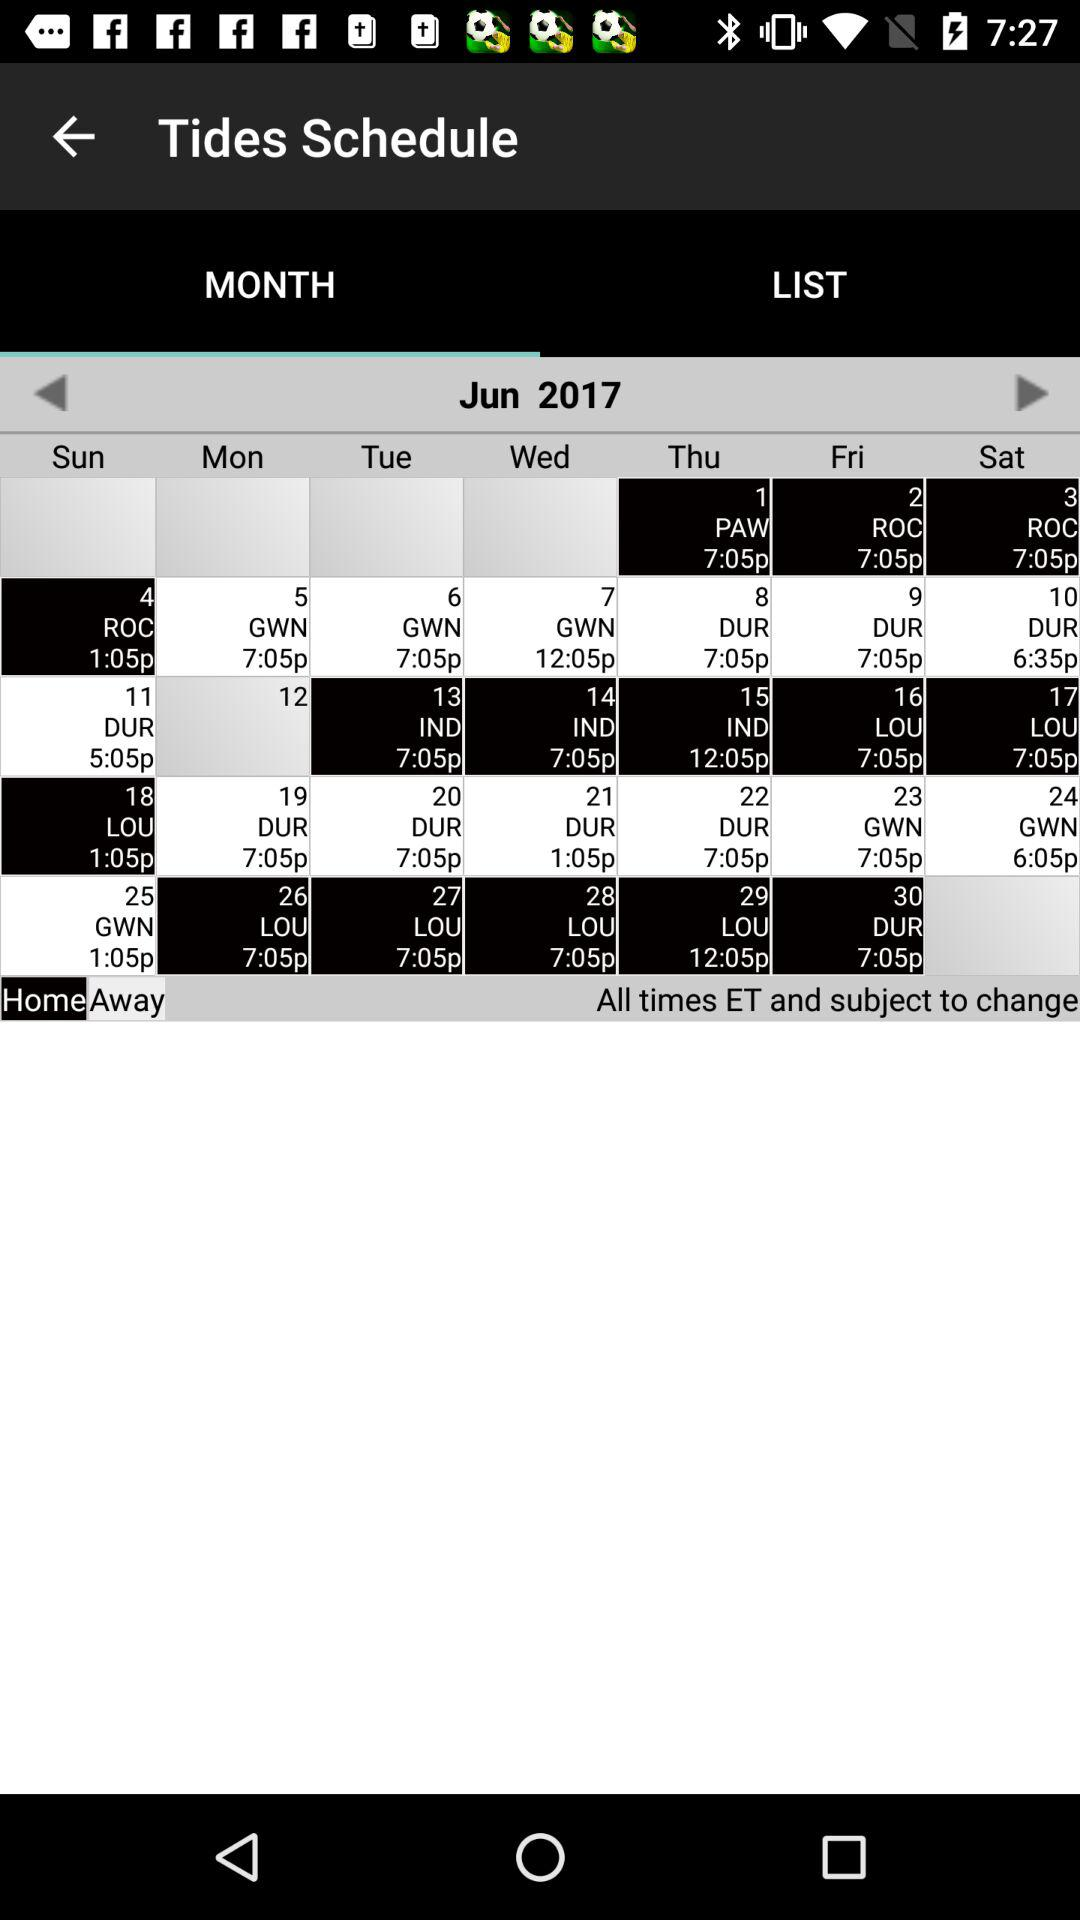Which tab is selected? The selected tab is "MONTH". 